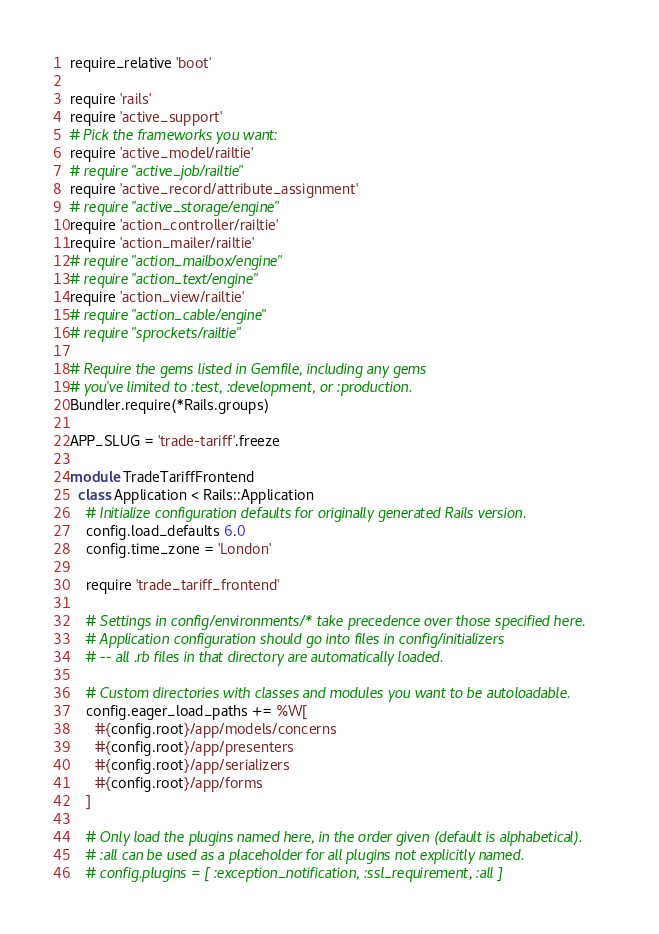<code> <loc_0><loc_0><loc_500><loc_500><_Ruby_>require_relative 'boot'

require 'rails'
require 'active_support'
# Pick the frameworks you want:
require 'active_model/railtie'
# require "active_job/railtie"
require 'active_record/attribute_assignment'
# require "active_storage/engine"
require 'action_controller/railtie'
require 'action_mailer/railtie'
# require "action_mailbox/engine"
# require "action_text/engine"
require 'action_view/railtie'
# require "action_cable/engine"
# require "sprockets/railtie"

# Require the gems listed in Gemfile, including any gems
# you've limited to :test, :development, or :production.
Bundler.require(*Rails.groups)

APP_SLUG = 'trade-tariff'.freeze

module TradeTariffFrontend
  class Application < Rails::Application
    # Initialize configuration defaults for originally generated Rails version.
    config.load_defaults 6.0
    config.time_zone = 'London'

    require 'trade_tariff_frontend'

    # Settings in config/environments/* take precedence over those specified here.
    # Application configuration should go into files in config/initializers
    # -- all .rb files in that directory are automatically loaded.

    # Custom directories with classes and modules you want to be autoloadable.
    config.eager_load_paths += %W[
      #{config.root}/app/models/concerns
      #{config.root}/app/presenters
      #{config.root}/app/serializers
      #{config.root}/app/forms
    ]

    # Only load the plugins named here, in the order given (default is alphabetical).
    # :all can be used as a placeholder for all plugins not explicitly named.
    # config.plugins = [ :exception_notification, :ssl_requirement, :all ]
</code> 